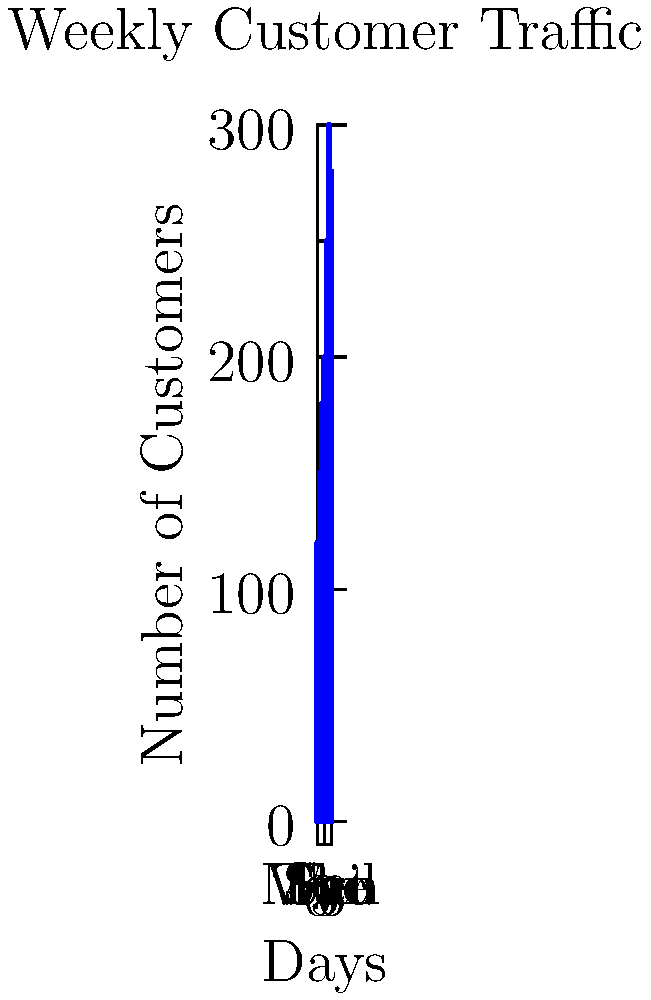Based on the chart showing weekly customer traffic at your beachside café, estimate the total volume of coffee beans needed for the week if each customer consumes an average of $30$ grams of coffee beans. Given that $1$ kilogram of coffee beans occupies approximately $2$ liters of volume, what is the minimum size of container (in liters) you should have to store a week's worth of coffee beans? Let's approach this step-by-step:

1) First, we need to calculate the total number of customers for the week:
   $120 + 150 + 180 + 200 + 250 + 300 + 280 = 1480$ customers

2) Now, let's calculate the total grams of coffee beans needed:
   $1480 \text{ customers} \times 30 \text{ grams per customer} = 44400 \text{ grams}$

3) Convert grams to kilograms:
   $44400 \text{ grams} = 44.4 \text{ kilograms}$

4) Now, we need to convert this to volume. We're given that 1 kg occupies 2 liters:
   $44.4 \text{ kg} \times 2 \text{ L/kg} = 88.8 \text{ liters}$

5) To ensure we have enough storage, we should round up to the nearest whole number:
   $88.8 \text{ liters} \approx 89 \text{ liters}$

Therefore, you need a container that can hold at least 89 liters of coffee beans.
Answer: 89 liters 